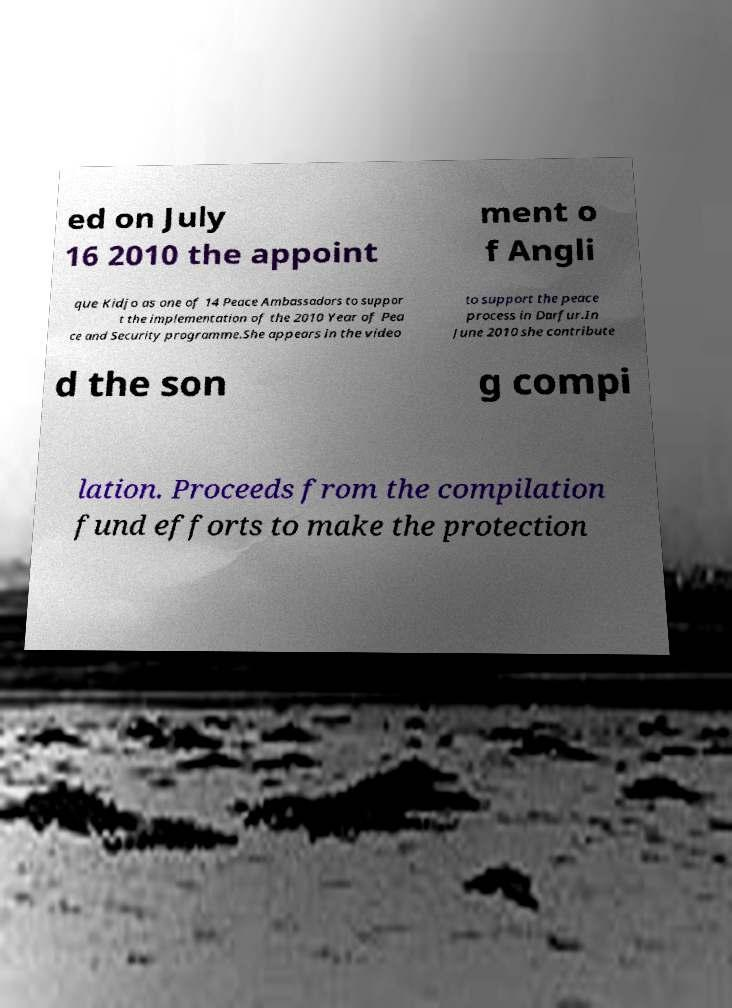For documentation purposes, I need the text within this image transcribed. Could you provide that? ed on July 16 2010 the appoint ment o f Angli que Kidjo as one of 14 Peace Ambassadors to suppor t the implementation of the 2010 Year of Pea ce and Security programme.She appears in the video to support the peace process in Darfur.In June 2010 she contribute d the son g compi lation. Proceeds from the compilation fund efforts to make the protection 